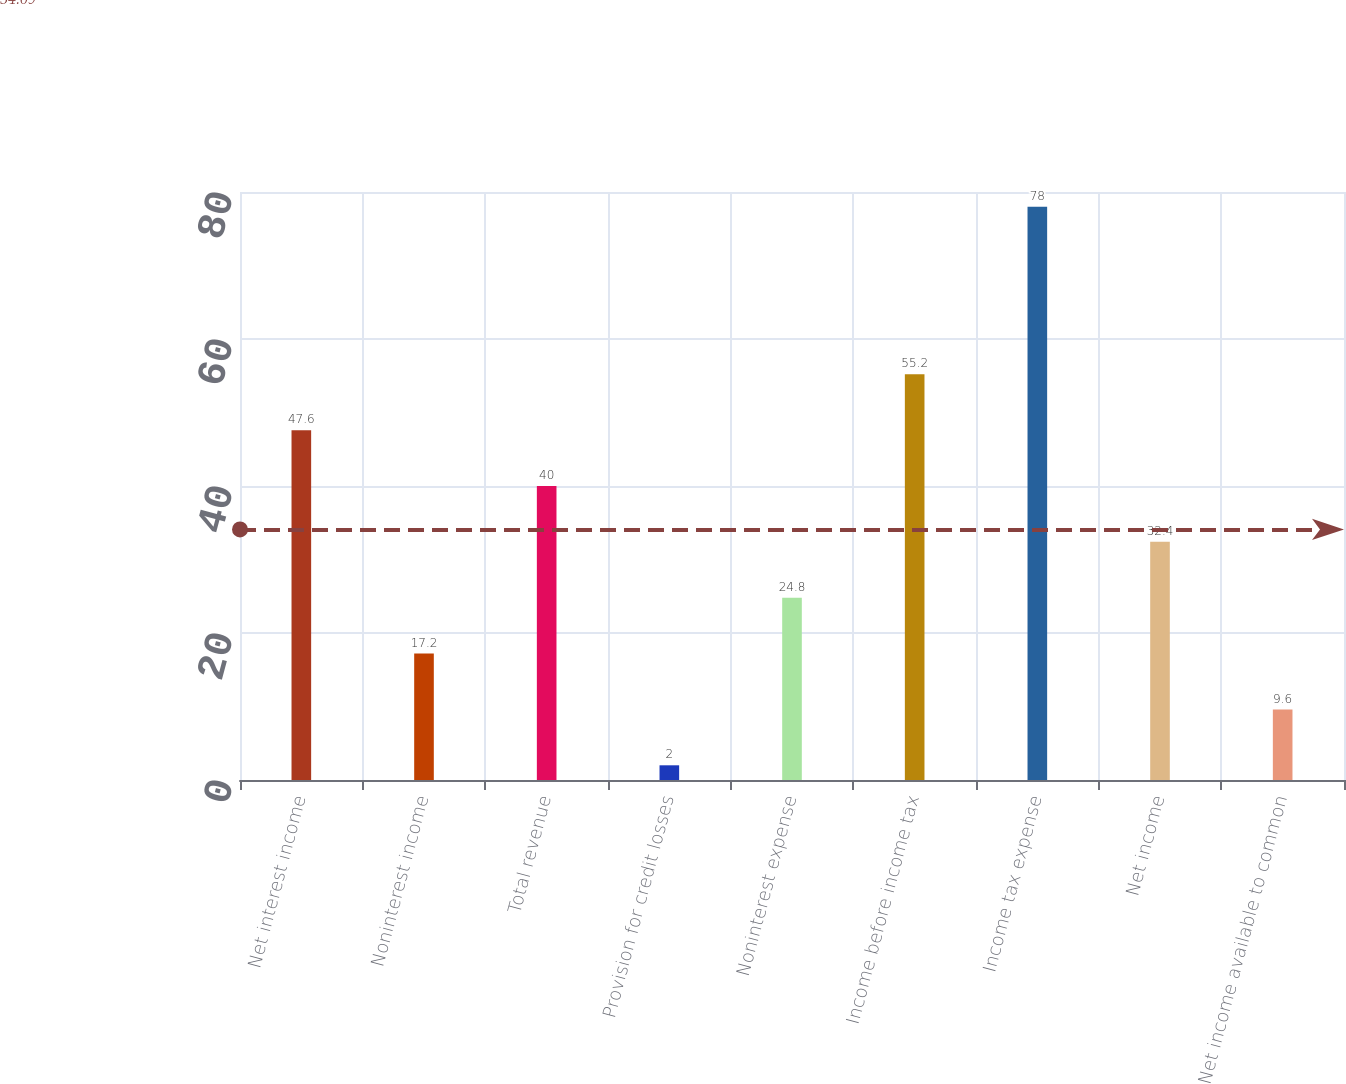Convert chart to OTSL. <chart><loc_0><loc_0><loc_500><loc_500><bar_chart><fcel>Net interest income<fcel>Noninterest income<fcel>Total revenue<fcel>Provision for credit losses<fcel>Noninterest expense<fcel>Income before income tax<fcel>Income tax expense<fcel>Net income<fcel>Net income available to common<nl><fcel>47.6<fcel>17.2<fcel>40<fcel>2<fcel>24.8<fcel>55.2<fcel>78<fcel>32.4<fcel>9.6<nl></chart> 